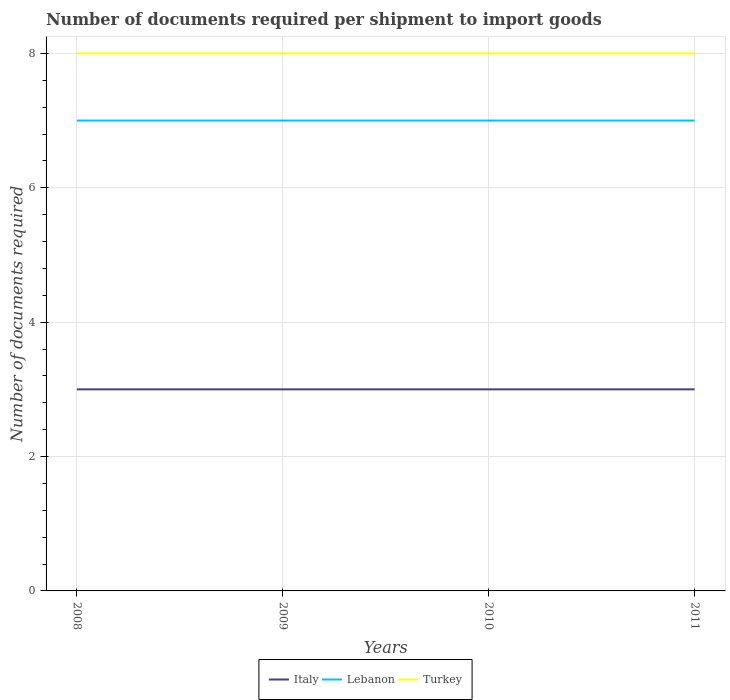Across all years, what is the maximum number of documents required per shipment to import goods in Turkey?
Ensure brevity in your answer.  8. In which year was the number of documents required per shipment to import goods in Italy maximum?
Offer a terse response. 2008. What is the difference between the highest and the second highest number of documents required per shipment to import goods in Lebanon?
Your answer should be very brief. 0. What is the difference between the highest and the lowest number of documents required per shipment to import goods in Turkey?
Provide a short and direct response. 0. Is the number of documents required per shipment to import goods in Italy strictly greater than the number of documents required per shipment to import goods in Lebanon over the years?
Offer a terse response. Yes. How many years are there in the graph?
Your response must be concise. 4. What is the difference between two consecutive major ticks on the Y-axis?
Provide a short and direct response. 2. Does the graph contain any zero values?
Ensure brevity in your answer.  No. Does the graph contain grids?
Keep it short and to the point. Yes. How many legend labels are there?
Ensure brevity in your answer.  3. What is the title of the graph?
Give a very brief answer. Number of documents required per shipment to import goods. What is the label or title of the Y-axis?
Your answer should be very brief. Number of documents required. What is the Number of documents required in Lebanon in 2009?
Ensure brevity in your answer.  7. What is the Number of documents required in Italy in 2011?
Give a very brief answer. 3. Across all years, what is the maximum Number of documents required in Lebanon?
Give a very brief answer. 7. Across all years, what is the maximum Number of documents required of Turkey?
Make the answer very short. 8. Across all years, what is the minimum Number of documents required of Turkey?
Keep it short and to the point. 8. What is the total Number of documents required of Italy in the graph?
Provide a short and direct response. 12. What is the total Number of documents required of Lebanon in the graph?
Your answer should be very brief. 28. What is the difference between the Number of documents required of Italy in 2008 and that in 2009?
Offer a very short reply. 0. What is the difference between the Number of documents required of Italy in 2008 and that in 2010?
Provide a succinct answer. 0. What is the difference between the Number of documents required of Turkey in 2008 and that in 2010?
Make the answer very short. 0. What is the difference between the Number of documents required of Lebanon in 2008 and that in 2011?
Make the answer very short. 0. What is the difference between the Number of documents required of Lebanon in 2009 and that in 2010?
Give a very brief answer. 0. What is the difference between the Number of documents required of Italy in 2009 and that in 2011?
Offer a terse response. 0. What is the difference between the Number of documents required in Lebanon in 2009 and that in 2011?
Your response must be concise. 0. What is the difference between the Number of documents required of Turkey in 2009 and that in 2011?
Offer a terse response. 0. What is the difference between the Number of documents required of Lebanon in 2010 and that in 2011?
Offer a terse response. 0. What is the difference between the Number of documents required of Turkey in 2010 and that in 2011?
Offer a terse response. 0. What is the difference between the Number of documents required of Italy in 2008 and the Number of documents required of Lebanon in 2010?
Offer a terse response. -4. What is the difference between the Number of documents required in Italy in 2008 and the Number of documents required in Lebanon in 2011?
Make the answer very short. -4. What is the difference between the Number of documents required in Lebanon in 2008 and the Number of documents required in Turkey in 2011?
Keep it short and to the point. -1. What is the difference between the Number of documents required of Italy in 2009 and the Number of documents required of Lebanon in 2010?
Provide a short and direct response. -4. What is the difference between the Number of documents required of Lebanon in 2009 and the Number of documents required of Turkey in 2010?
Offer a terse response. -1. What is the difference between the Number of documents required of Italy in 2010 and the Number of documents required of Lebanon in 2011?
Ensure brevity in your answer.  -4. What is the difference between the Number of documents required in Italy in 2010 and the Number of documents required in Turkey in 2011?
Provide a short and direct response. -5. What is the average Number of documents required in Turkey per year?
Make the answer very short. 8. In the year 2008, what is the difference between the Number of documents required of Lebanon and Number of documents required of Turkey?
Provide a short and direct response. -1. In the year 2009, what is the difference between the Number of documents required in Italy and Number of documents required in Lebanon?
Your response must be concise. -4. In the year 2009, what is the difference between the Number of documents required of Italy and Number of documents required of Turkey?
Your answer should be compact. -5. In the year 2009, what is the difference between the Number of documents required in Lebanon and Number of documents required in Turkey?
Make the answer very short. -1. In the year 2010, what is the difference between the Number of documents required in Lebanon and Number of documents required in Turkey?
Offer a terse response. -1. In the year 2011, what is the difference between the Number of documents required of Italy and Number of documents required of Lebanon?
Offer a terse response. -4. In the year 2011, what is the difference between the Number of documents required of Italy and Number of documents required of Turkey?
Ensure brevity in your answer.  -5. In the year 2011, what is the difference between the Number of documents required of Lebanon and Number of documents required of Turkey?
Provide a succinct answer. -1. What is the ratio of the Number of documents required of Lebanon in 2008 to that in 2009?
Give a very brief answer. 1. What is the ratio of the Number of documents required in Italy in 2008 to that in 2010?
Offer a terse response. 1. What is the ratio of the Number of documents required in Lebanon in 2008 to that in 2010?
Offer a terse response. 1. What is the ratio of the Number of documents required in Turkey in 2008 to that in 2010?
Offer a terse response. 1. What is the ratio of the Number of documents required in Italy in 2008 to that in 2011?
Provide a succinct answer. 1. What is the ratio of the Number of documents required in Lebanon in 2008 to that in 2011?
Your response must be concise. 1. What is the ratio of the Number of documents required in Italy in 2009 to that in 2010?
Provide a short and direct response. 1. What is the ratio of the Number of documents required in Turkey in 2009 to that in 2011?
Ensure brevity in your answer.  1. What is the difference between the highest and the second highest Number of documents required in Italy?
Provide a succinct answer. 0. What is the difference between the highest and the lowest Number of documents required in Italy?
Your answer should be very brief. 0. 